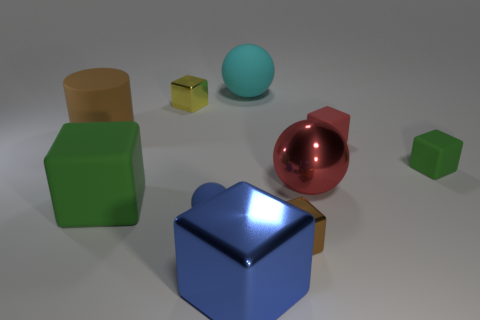Subtract 1 blocks. How many blocks are left? 5 Subtract all small rubber cubes. How many cubes are left? 4 Subtract all green blocks. How many blocks are left? 4 Subtract all blue blocks. Subtract all red spheres. How many blocks are left? 5 Subtract all spheres. How many objects are left? 7 Add 7 tiny green cubes. How many tiny green cubes exist? 8 Subtract 1 cyan balls. How many objects are left? 9 Subtract all brown objects. Subtract all large green things. How many objects are left? 7 Add 7 rubber cubes. How many rubber cubes are left? 10 